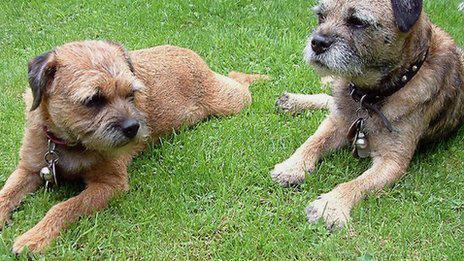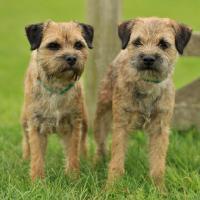The first image is the image on the left, the second image is the image on the right. For the images displayed, is the sentence "An image shows two dogs resting together with something pillow-like." factually correct? Answer yes or no. No. The first image is the image on the left, the second image is the image on the right. Considering the images on both sides, is "Two terriers are standing in the grass with their front paws on a branch." valid? Answer yes or no. No. The first image is the image on the left, the second image is the image on the right. For the images shown, is this caption "At least one image shows two dogs napping together." true? Answer yes or no. No. The first image is the image on the left, the second image is the image on the right. Analyze the images presented: Is the assertion "In one of the images there are two dogs resting their heads on a pillow." valid? Answer yes or no. No. 